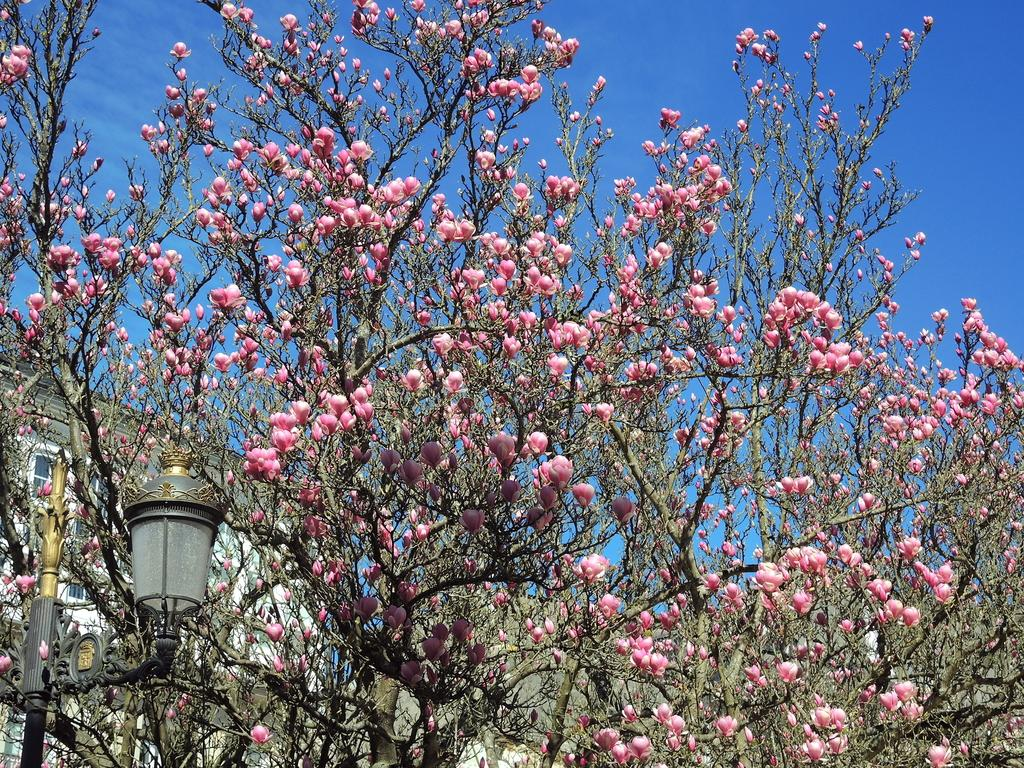What type of flowers can be seen in the image? There are pink color flowers in the image. What other natural elements are present in the image? There are trees in the image. What artificial element can be seen in the image? There is a light-pole in the image. What type of structure is visible in the image? There is a building in the image. What architectural feature can be seen on the building? There are windows in the image. What is the color of the sky in the image? The sky is blue and white in color. Can you see a patch of grass on the neck of the building in the image? There is no patch of grass on the neck of the building in the image, as the building does not have a neck. 